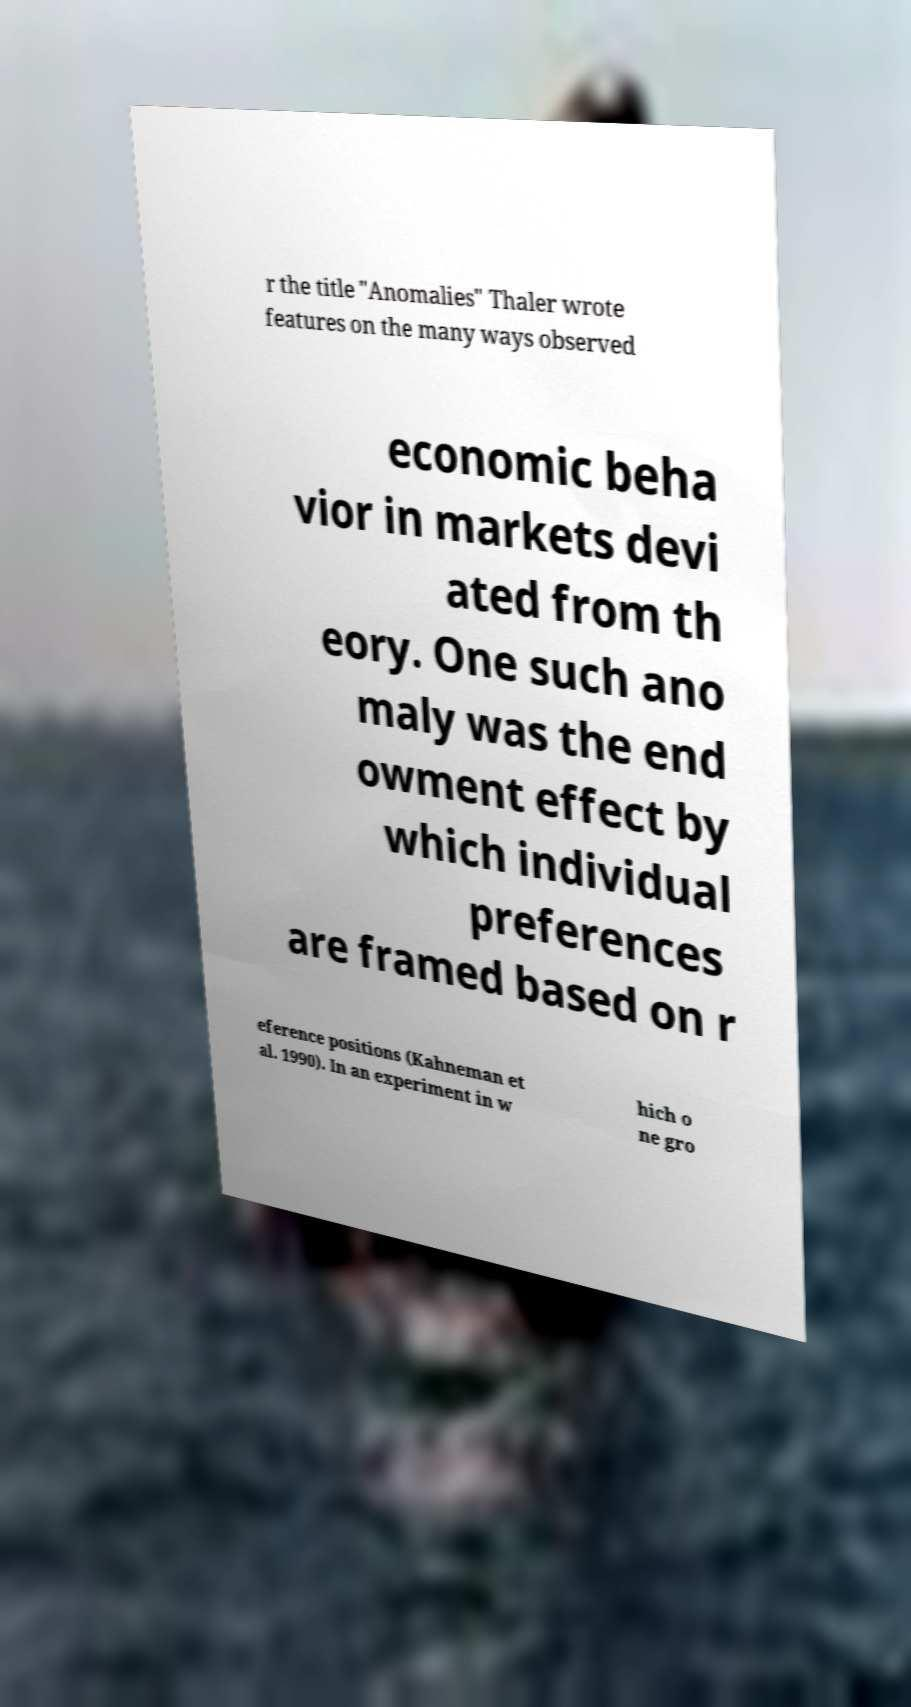There's text embedded in this image that I need extracted. Can you transcribe it verbatim? r the title "Anomalies" Thaler wrote features on the many ways observed economic beha vior in markets devi ated from th eory. One such ano maly was the end owment effect by which individual preferences are framed based on r eference positions (Kahneman et al. 1990). In an experiment in w hich o ne gro 